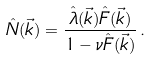Convert formula to latex. <formula><loc_0><loc_0><loc_500><loc_500>\hat { N } ( \vec { k } ) = \frac { \hat { \lambda } ( \vec { k } ) \hat { F } ( \vec { k } ) } { 1 - \nu \hat { F } ( \vec { k } ) } \, .</formula> 